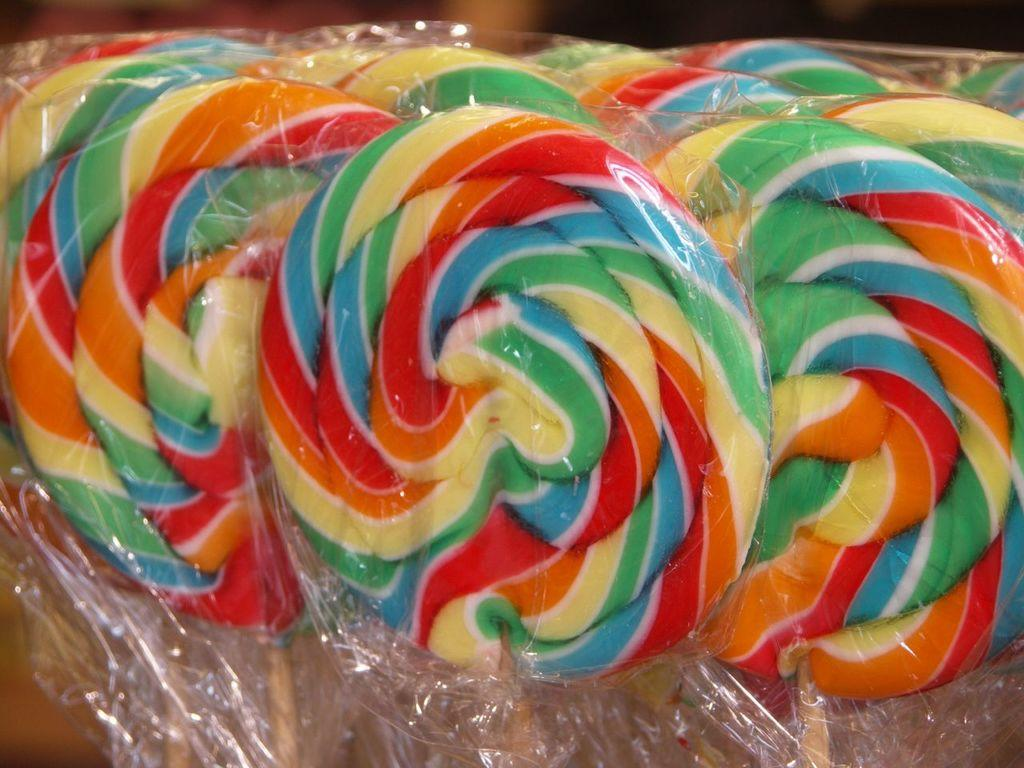What type of candy is present in the image? There are lollipops in the image. What type of rod can be seen holding up the snow in the image? There is no rod or snow present in the image; it only features lollipops. 